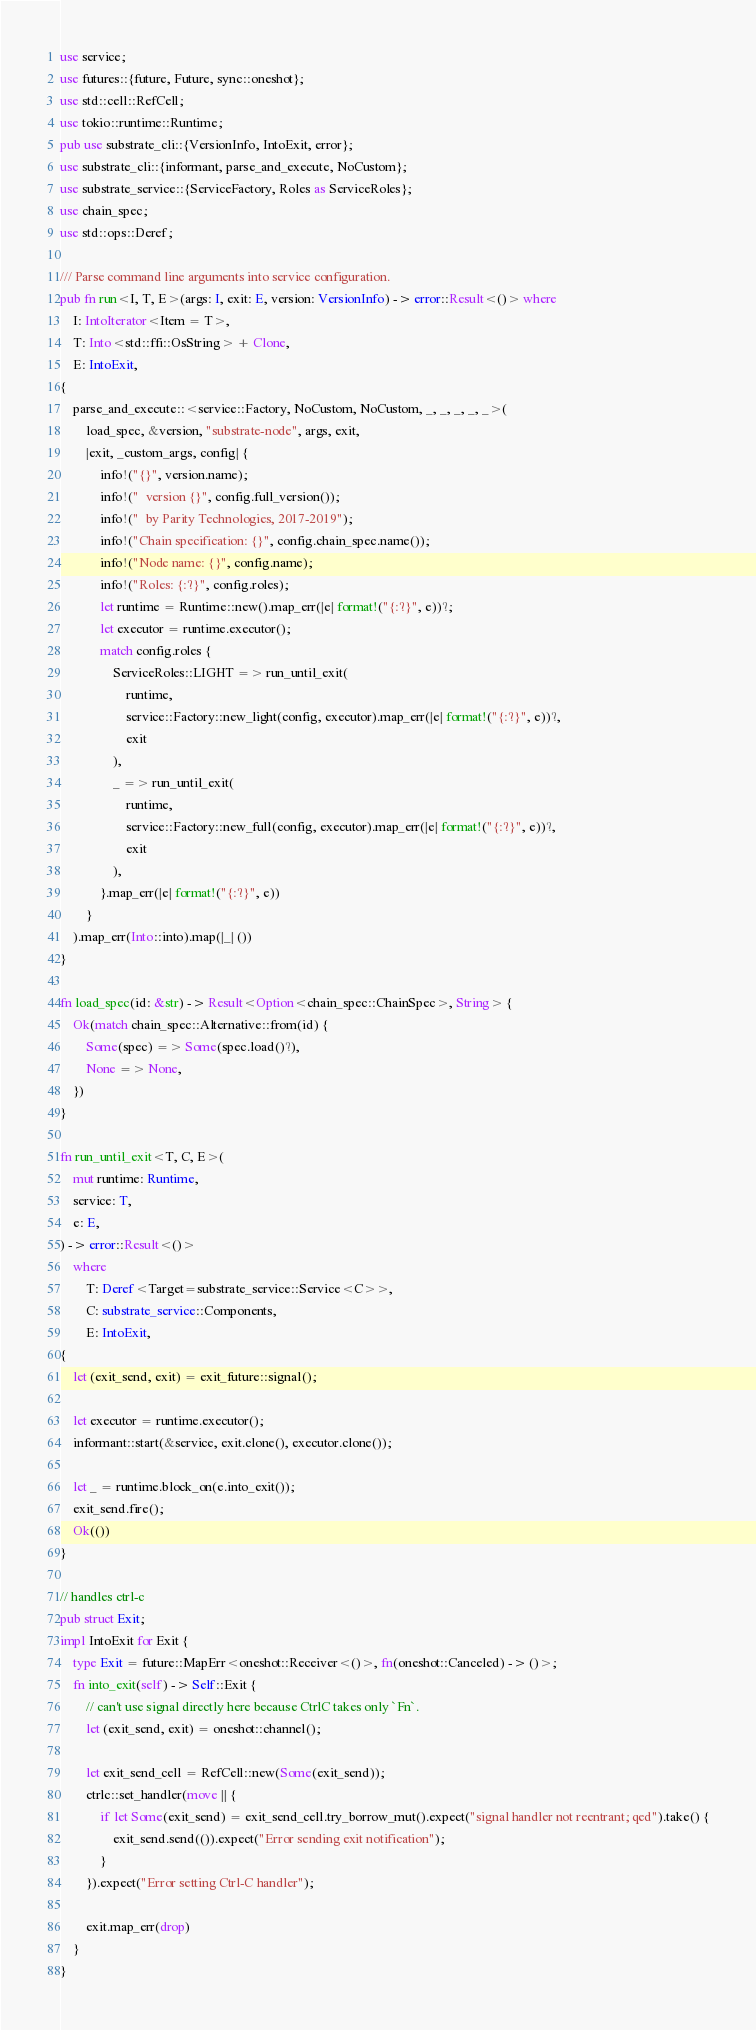<code> <loc_0><loc_0><loc_500><loc_500><_Rust_>use service;
use futures::{future, Future, sync::oneshot};
use std::cell::RefCell;
use tokio::runtime::Runtime;
pub use substrate_cli::{VersionInfo, IntoExit, error};
use substrate_cli::{informant, parse_and_execute, NoCustom};
use substrate_service::{ServiceFactory, Roles as ServiceRoles};
use chain_spec;
use std::ops::Deref;

/// Parse command line arguments into service configuration.
pub fn run<I, T, E>(args: I, exit: E, version: VersionInfo) -> error::Result<()> where
	I: IntoIterator<Item = T>,
	T: Into<std::ffi::OsString> + Clone,
	E: IntoExit,
{
	parse_and_execute::<service::Factory, NoCustom, NoCustom, _, _, _, _, _>(
		load_spec, &version, "substrate-node", args, exit,
	 	|exit, _custom_args, config| {
			info!("{}", version.name);
			info!("  version {}", config.full_version());
			info!("  by Parity Technologies, 2017-2019");
			info!("Chain specification: {}", config.chain_spec.name());
			info!("Node name: {}", config.name);
			info!("Roles: {:?}", config.roles);
			let runtime = Runtime::new().map_err(|e| format!("{:?}", e))?;
			let executor = runtime.executor();
			match config.roles {
				ServiceRoles::LIGHT => run_until_exit(
					runtime,
				 	service::Factory::new_light(config, executor).map_err(|e| format!("{:?}", e))?,
					exit
				),
				_ => run_until_exit(
					runtime,
					service::Factory::new_full(config, executor).map_err(|e| format!("{:?}", e))?,
					exit
				),
			}.map_err(|e| format!("{:?}", e))
		}
	).map_err(Into::into).map(|_| ())
}

fn load_spec(id: &str) -> Result<Option<chain_spec::ChainSpec>, String> {
	Ok(match chain_spec::Alternative::from(id) {
		Some(spec) => Some(spec.load()?),
		None => None,
	})
}

fn run_until_exit<T, C, E>(
	mut runtime: Runtime,
	service: T,
	e: E,
) -> error::Result<()>
	where
		T: Deref<Target=substrate_service::Service<C>>,
		C: substrate_service::Components,
		E: IntoExit,
{
	let (exit_send, exit) = exit_future::signal();

	let executor = runtime.executor();
	informant::start(&service, exit.clone(), executor.clone());

	let _ = runtime.block_on(e.into_exit());
	exit_send.fire();
	Ok(())
}

// handles ctrl-c
pub struct Exit;
impl IntoExit for Exit {
	type Exit = future::MapErr<oneshot::Receiver<()>, fn(oneshot::Canceled) -> ()>;
	fn into_exit(self) -> Self::Exit {
		// can't use signal directly here because CtrlC takes only `Fn`.
		let (exit_send, exit) = oneshot::channel();

		let exit_send_cell = RefCell::new(Some(exit_send));
		ctrlc::set_handler(move || {
			if let Some(exit_send) = exit_send_cell.try_borrow_mut().expect("signal handler not reentrant; qed").take() {
				exit_send.send(()).expect("Error sending exit notification");
			}
		}).expect("Error setting Ctrl-C handler");

		exit.map_err(drop)
	}
}
</code> 